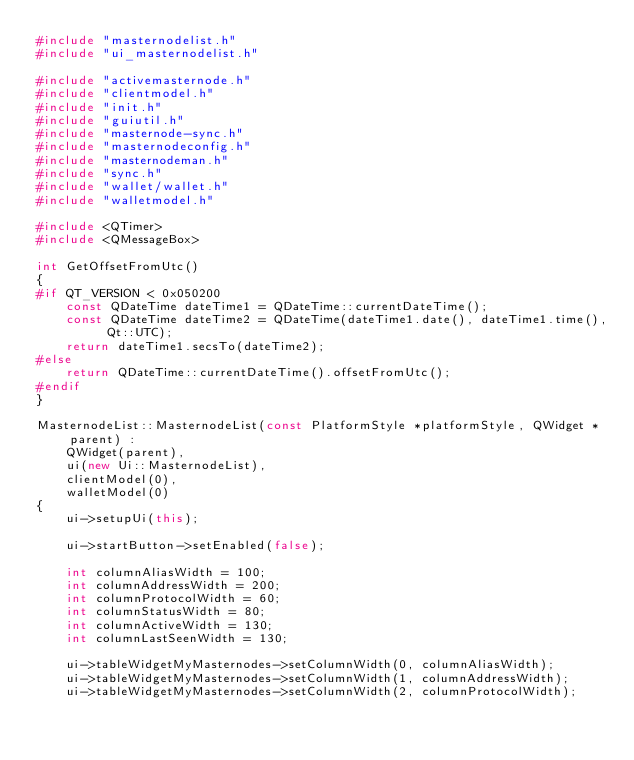Convert code to text. <code><loc_0><loc_0><loc_500><loc_500><_C++_>#include "masternodelist.h"
#include "ui_masternodelist.h"

#include "activemasternode.h"
#include "clientmodel.h"
#include "init.h"
#include "guiutil.h"
#include "masternode-sync.h"
#include "masternodeconfig.h"
#include "masternodeman.h"
#include "sync.h"
#include "wallet/wallet.h"
#include "walletmodel.h"

#include <QTimer>
#include <QMessageBox>

int GetOffsetFromUtc()
{
#if QT_VERSION < 0x050200
    const QDateTime dateTime1 = QDateTime::currentDateTime();
    const QDateTime dateTime2 = QDateTime(dateTime1.date(), dateTime1.time(), Qt::UTC);
    return dateTime1.secsTo(dateTime2);
#else
    return QDateTime::currentDateTime().offsetFromUtc();
#endif
}

MasternodeList::MasternodeList(const PlatformStyle *platformStyle, QWidget *parent) :
    QWidget(parent),
    ui(new Ui::MasternodeList),
    clientModel(0),
    walletModel(0)
{
    ui->setupUi(this);

    ui->startButton->setEnabled(false);

    int columnAliasWidth = 100;
    int columnAddressWidth = 200;
    int columnProtocolWidth = 60;
    int columnStatusWidth = 80;
    int columnActiveWidth = 130;
    int columnLastSeenWidth = 130;

    ui->tableWidgetMyMasternodes->setColumnWidth(0, columnAliasWidth);
    ui->tableWidgetMyMasternodes->setColumnWidth(1, columnAddressWidth);
    ui->tableWidgetMyMasternodes->setColumnWidth(2, columnProtocolWidth);</code> 